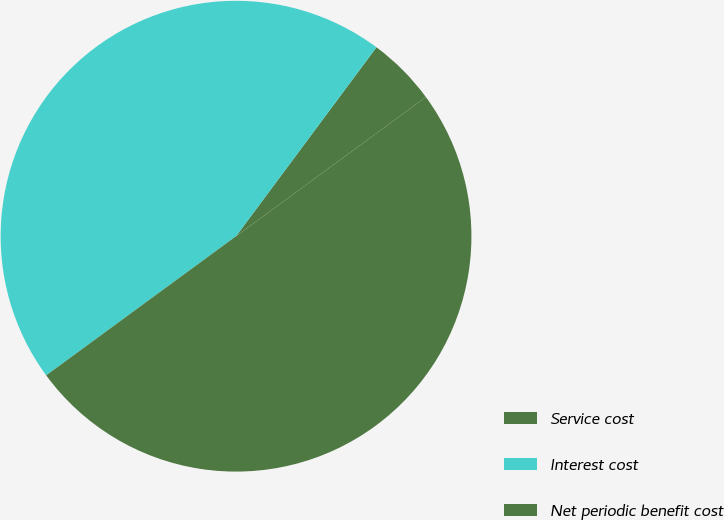<chart> <loc_0><loc_0><loc_500><loc_500><pie_chart><fcel>Service cost<fcel>Interest cost<fcel>Net periodic benefit cost<nl><fcel>4.76%<fcel>45.24%<fcel>50.0%<nl></chart> 